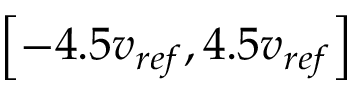Convert formula to latex. <formula><loc_0><loc_0><loc_500><loc_500>\left [ - 4 . 5 v _ { r e f } , 4 . 5 v _ { r e f } \right ]</formula> 